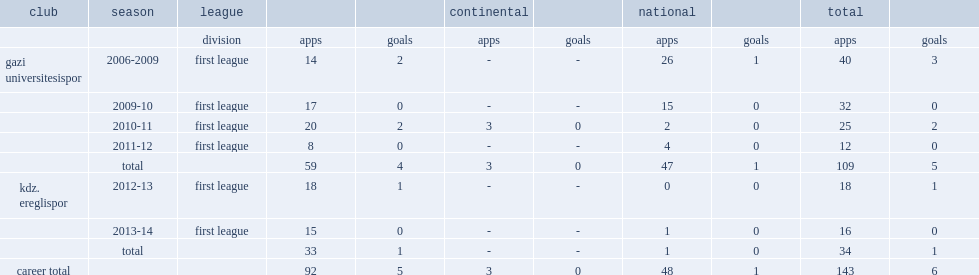In the 2009-10 season, which club did zubeyde kaya participate in first league? Gazi universitesispor. 